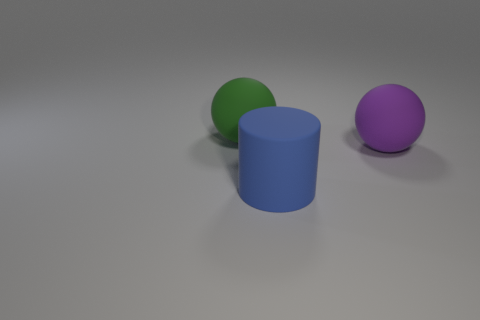There is a big matte thing that is in front of the large purple sphere; what shape is it?
Keep it short and to the point. Cylinder. What number of gray things are large rubber cylinders or matte objects?
Offer a terse response. 0. What number of large balls are behind the purple matte ball?
Make the answer very short. 1. How many blocks are blue things or big green rubber objects?
Your answer should be compact. 0. There is another big object that is the same shape as the large green object; what material is it?
Give a very brief answer. Rubber. What is the size of the blue cylinder that is the same material as the green object?
Your response must be concise. Large. There is a rubber object that is behind the big purple thing; does it have the same shape as the blue matte thing that is right of the green object?
Your answer should be very brief. No. There is a large sphere that is made of the same material as the big purple thing; what color is it?
Provide a succinct answer. Green. Is the size of the rubber thing right of the large blue rubber cylinder the same as the thing that is behind the purple object?
Give a very brief answer. Yes. There is a large object that is both in front of the green matte ball and on the left side of the purple matte ball; what shape is it?
Give a very brief answer. Cylinder. 